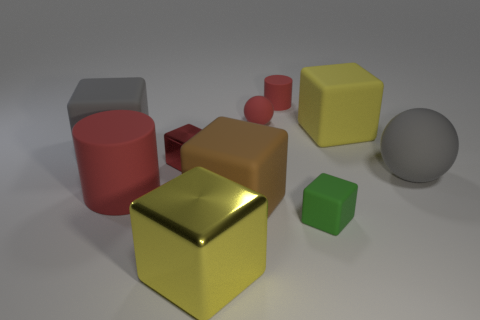Subtract all brown matte cubes. How many cubes are left? 5 Subtract all cyan cylinders. How many yellow cubes are left? 2 Subtract 2 balls. How many balls are left? 0 Subtract all yellow cubes. How many cubes are left? 4 Subtract all blocks. How many objects are left? 4 Add 8 red matte spheres. How many red matte spheres are left? 9 Add 3 yellow rubber objects. How many yellow rubber objects exist? 4 Subtract 1 green blocks. How many objects are left? 9 Subtract all blue spheres. Subtract all cyan cylinders. How many spheres are left? 2 Subtract all large gray cubes. Subtract all tiny red things. How many objects are left? 6 